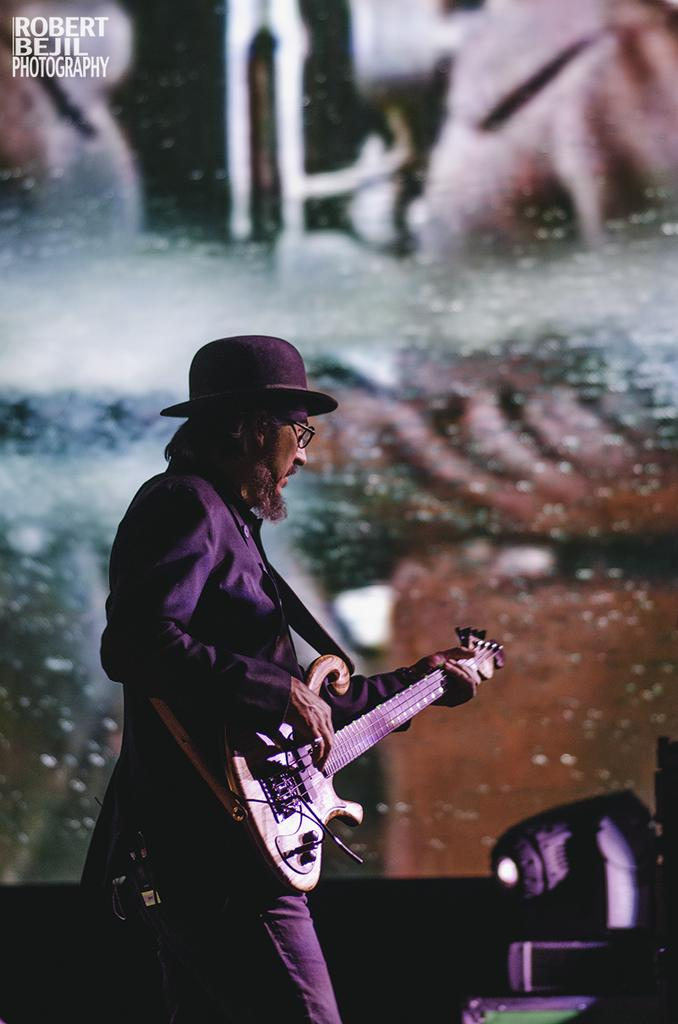What is the person in the image doing? The person is standing in the image. What object is the person holding? The person is holding a guitar. What accessory is the person wearing? The person is wearing glasses. What color is the dress the person is wearing? The person is wearing a black dress. What device is attached to the person's waist? There is a microphone attached to the person's waist. How does the person navigate the steep slope in the image? There is no steep slope present in the image; the person is standing on a flat surface. 